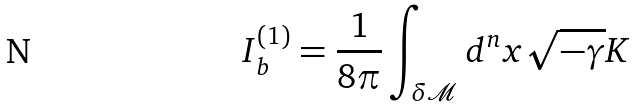Convert formula to latex. <formula><loc_0><loc_0><loc_500><loc_500>I _ { b } ^ { ( 1 ) } = \frac { 1 } { 8 \pi } \int _ { \delta \mathcal { M } } d ^ { n } x \sqrt { - \gamma } K</formula> 